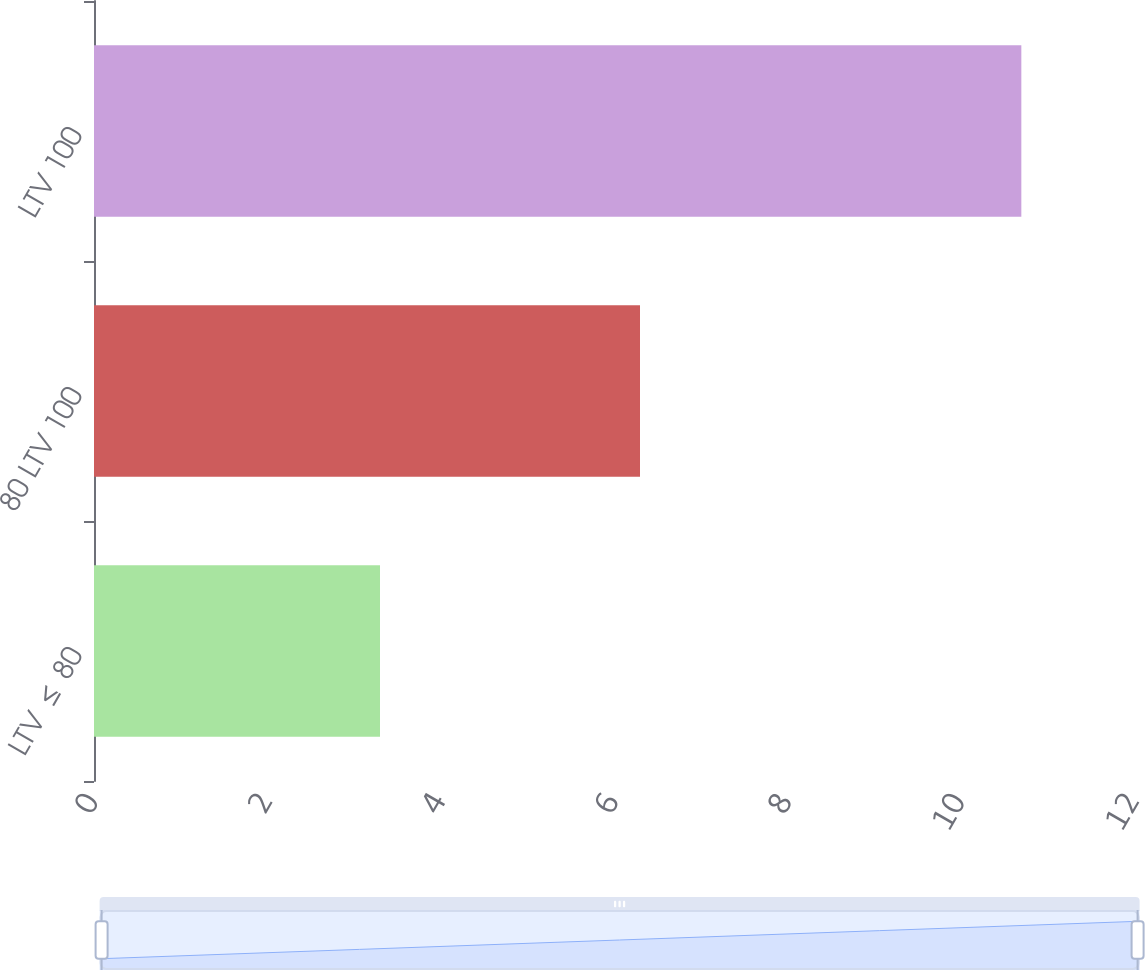<chart> <loc_0><loc_0><loc_500><loc_500><bar_chart><fcel>LTV ≤ 80<fcel>80 LTV 100<fcel>LTV 100<nl><fcel>3.3<fcel>6.3<fcel>10.7<nl></chart> 